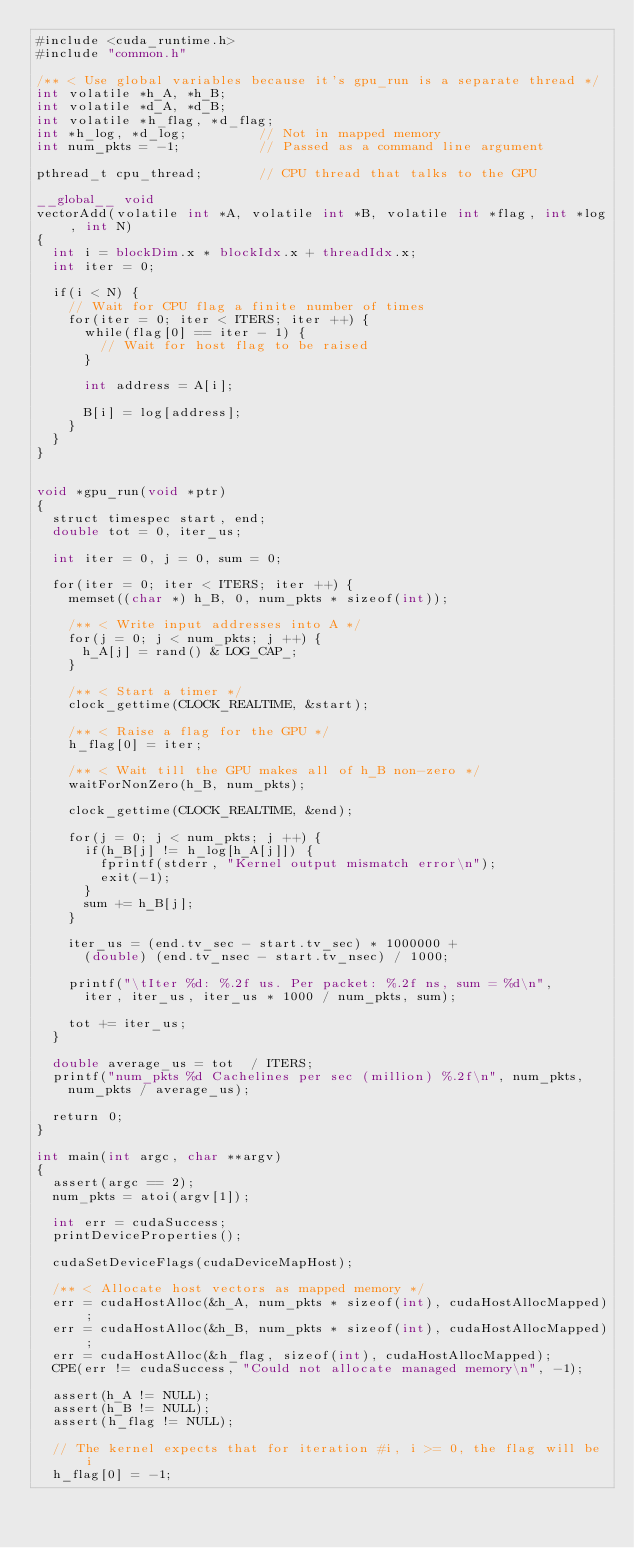Convert code to text. <code><loc_0><loc_0><loc_500><loc_500><_Cuda_>#include <cuda_runtime.h>
#include "common.h"

/** < Use global variables because it's gpu_run is a separate thread */
int volatile *h_A, *h_B;
int volatile *d_A, *d_B;
int volatile *h_flag, *d_flag;
int *h_log, *d_log;					// Not in mapped memory 
int num_pkts = -1;					// Passed as a command line argument

pthread_t cpu_thread;				// CPU thread that talks to the GPU

__global__ void
vectorAdd(volatile int *A, volatile int *B, volatile int *flag, int *log, int N)
{
	int i = blockDim.x * blockIdx.x + threadIdx.x;
	int iter = 0;
	
	if(i < N) {
		// Wait for CPU flag a finite number of times
		for(iter = 0; iter < ITERS; iter ++) {
			while(flag[0] == iter - 1) {
				// Wait for host flag to be raised
			}

			int address = A[i];

			B[i] = log[address];
		}
	}
}


void *gpu_run(void *ptr)
{
	struct timespec start, end;
	double tot = 0, iter_us;

	int iter = 0, j = 0, sum = 0;

	for(iter = 0; iter < ITERS; iter ++) {
		memset((char *) h_B, 0, num_pkts * sizeof(int));

		/** < Write input addresses into A */
		for(j = 0; j < num_pkts; j ++) {
			h_A[j] = rand() & LOG_CAP_;
		}

		/** < Start a timer */
		clock_gettime(CLOCK_REALTIME, &start);

		/** < Raise a flag for the GPU */
		h_flag[0] = iter;

		/** < Wait till the GPU makes all of h_B non-zero */
		waitForNonZero(h_B, num_pkts);

		clock_gettime(CLOCK_REALTIME, &end);

		for(j = 0; j < num_pkts; j ++) {
			if(h_B[j] != h_log[h_A[j]]) {
				fprintf(stderr, "Kernel output mismatch error\n");
				exit(-1);
			}
			sum += h_B[j];
		}

		iter_us = (end.tv_sec - start.tv_sec) * 1000000 + 
			(double) (end.tv_nsec - start.tv_nsec) / 1000;

		printf("\tIter %d: %.2f us. Per packet: %.2f ns, sum = %d\n", 
			iter, iter_us, iter_us * 1000 / num_pkts, sum);

		tot += iter_us;
	}

	double average_us = tot	 / ITERS;
	printf("num_pkts %d Cachelines per sec (million) %.2f\n", num_pkts,
		num_pkts / average_us);

	return 0;
}

int main(int argc, char **argv)
{
	assert(argc == 2);
	num_pkts = atoi(argv[1]);

	int err = cudaSuccess;
	printDeviceProperties();

	cudaSetDeviceFlags(cudaDeviceMapHost);

	/** < Allocate host vectors as mapped memory */
	err = cudaHostAlloc(&h_A, num_pkts * sizeof(int), cudaHostAllocMapped);
	err = cudaHostAlloc(&h_B, num_pkts * sizeof(int), cudaHostAllocMapped);
	err = cudaHostAlloc(&h_flag, sizeof(int), cudaHostAllocMapped);
	CPE(err != cudaSuccess, "Could not allocate managed memory\n", -1);

	assert(h_A != NULL);
	assert(h_B != NULL);
	assert(h_flag != NULL);

	// The kernel expects that for iteration #i, i >= 0, the flag will be i
	h_flag[0] = -1;
</code> 